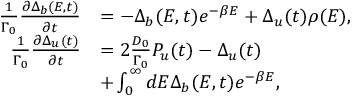Convert formula to latex. <formula><loc_0><loc_0><loc_500><loc_500>\begin{array} { r l } { \frac { 1 } { \Gamma _ { 0 } } \frac { \partial \Delta _ { b } ( E , t ) } { \partial t } } & { = - \Delta _ { b } ( E , t ) e ^ { - \beta E } + \Delta _ { u } ( t ) \rho ( E ) , } \\ { \frac { 1 } { \Gamma _ { 0 } } \frac { \partial \Delta _ { u } ( t ) } { \partial t } } & { = 2 \frac { D _ { 0 } } { \Gamma _ { 0 } } P _ { u } ( t ) - \Delta _ { u } ( t ) } \\ & { + \int _ { 0 } ^ { \infty } d E \Delta _ { b } ( E , t ) e ^ { - \beta E } , } \end{array}</formula> 